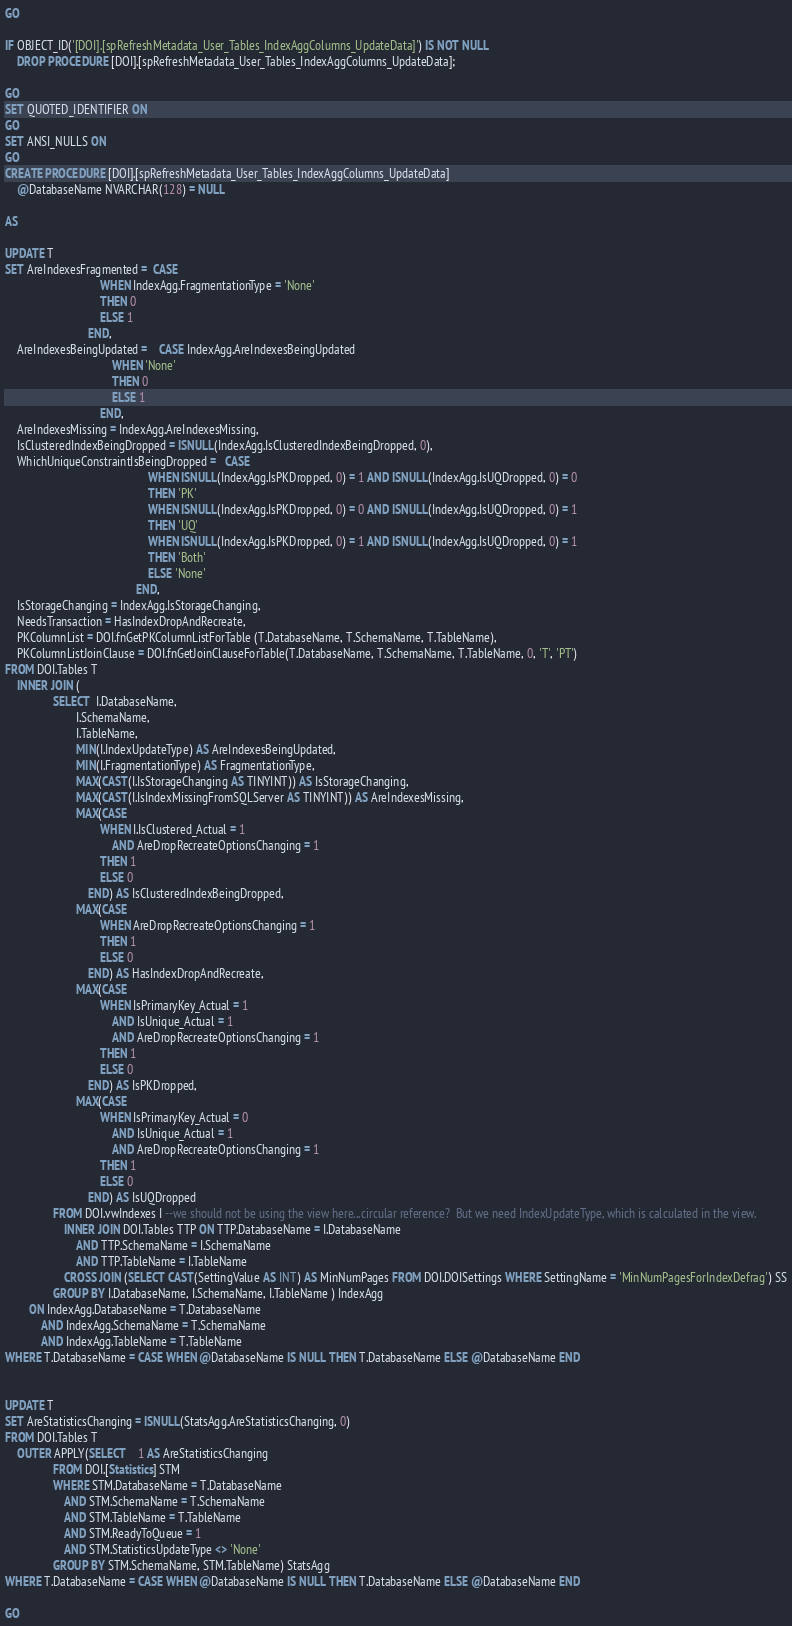<code> <loc_0><loc_0><loc_500><loc_500><_SQL_>
GO

IF OBJECT_ID('[DOI].[spRefreshMetadata_User_Tables_IndexAggColumns_UpdateData]') IS NOT NULL
	DROP PROCEDURE [DOI].[spRefreshMetadata_User_Tables_IndexAggColumns_UpdateData];

GO
SET QUOTED_IDENTIFIER ON
GO
SET ANSI_NULLS ON
GO
CREATE PROCEDURE [DOI].[spRefreshMetadata_User_Tables_IndexAggColumns_UpdateData]
    @DatabaseName NVARCHAR(128) = NULL

AS

UPDATE T
SET AreIndexesFragmented =  CASE 
			                    WHEN IndexAgg.FragmentationType = 'None'
			                    THEN 0
			                    ELSE 1 
		                    END,
	AreIndexesBeingUpdated =    CASE IndexAgg.AreIndexesBeingUpdated
			                        WHEN 'None'
			                        THEN 0
			                        ELSE 1
		                        END,
	AreIndexesMissing = IndexAgg.AreIndexesMissing,
    IsClusteredIndexBeingDropped = ISNULL(IndexAgg.IsClusteredIndexBeingDropped, 0),
	WhichUniqueConstraintIsBeingDropped =   CASE
		                                        WHEN ISNULL(IndexAgg.IsPKDropped, 0) = 1 AND ISNULL(IndexAgg.IsUQDropped, 0) = 0
		                                        THEN 'PK' 
		                                        WHEN ISNULL(IndexAgg.IsPKDropped, 0) = 0 AND ISNULL(IndexAgg.IsUQDropped, 0) = 1
		                                        THEN 'UQ'
		                                        WHEN ISNULL(IndexAgg.IsPKDropped, 0) = 1 AND ISNULL(IndexAgg.IsUQDropped, 0) = 1
		                                        THEN 'Both'
		                                        ELSE 'None'
	                                        END,
	IsStorageChanging = IndexAgg.IsStorageChanging,
	NeedsTransaction = HasIndexDropAndRecreate,
    PKColumnList = DOI.fnGetPKColumnListForTable (T.DatabaseName, T.SchemaName, T.TableName),
    PKColumnListJoinClause = DOI.fnGetJoinClauseForTable(T.DatabaseName, T.SchemaName, T.TableName, 0, 'T', 'PT')
FROM DOI.Tables T
    INNER JOIN (
                SELECT  I.DatabaseName,
                        I.SchemaName,
                        I.TableName,
                        MIN(I.IndexUpdateType) AS AreIndexesBeingUpdated,
                        MIN(I.FragmentationType) AS FragmentationType,
                        MAX(CAST(I.IsStorageChanging AS TINYINT)) AS IsStorageChanging,
                        MAX(CAST(I.IsIndexMissingFromSQLServer AS TINYINT)) AS AreIndexesMissing,
                        MAX(CASE 
                                WHEN I.IsClustered_Actual = 1
                                    AND AreDropRecreateOptionsChanging = 1
                                THEN 1
                                ELSE 0
                            END) AS IsClusteredIndexBeingDropped,
                        MAX(CASE 
				                WHEN AreDropRecreateOptionsChanging = 1
				                THEN 1 
				                ELSE 0 
			                END) AS HasIndexDropAndRecreate,
                        MAX(CASE
                                WHEN IsPrimaryKey_Actual = 1 
									AND IsUnique_Actual = 1
                                    AND AreDropRecreateOptionsChanging = 1
                                THEN 1
                                ELSE 0
                            END) AS IsPKDropped, 
                        MAX(CASE
                                WHEN IsPrimaryKey_Actual = 0 
									AND IsUnique_Actual = 1
                                    AND AreDropRecreateOptionsChanging = 1
                                THEN 1
                                ELSE 0
                            END) AS IsUQDropped
                FROM DOI.vwIndexes I --we should not be using the view here...circular reference?  But we need IndexUpdateType, which is calculated in the view.
                    INNER JOIN DOI.Tables TTP ON TTP.DatabaseName = I.DatabaseName
                        AND TTP.SchemaName = I.SchemaName
                        AND TTP.TableName = I.TableName
                    CROSS JOIN (SELECT CAST(SettingValue AS INT) AS MinNumPages FROM DOI.DOISettings WHERE SettingName = 'MinNumPagesForIndexDefrag') SS
                GROUP BY I.DatabaseName, I.SchemaName, I.TableName ) IndexAgg
        ON IndexAgg.DatabaseName = T.DatabaseName
            AND IndexAgg.SchemaName = T.SchemaName
            AND IndexAgg.TableName = T.TableName
WHERE T.DatabaseName = CASE WHEN @DatabaseName IS NULL THEN T.DatabaseName ELSE @DatabaseName END 


UPDATE T
SET AreStatisticsChanging = ISNULL(StatsAgg.AreStatisticsChanging, 0)
FROM DOI.Tables T
    OUTER APPLY(SELECT	1 AS AreStatisticsChanging
				FROM DOI.[Statistics] STM
				WHERE STM.DatabaseName = T.DatabaseName
                    AND STM.SchemaName = T.SchemaName
					AND STM.TableName = T.TableName
                    AND STM.ReadyToQueue = 1
					AND STM.StatisticsUpdateType <> 'None'
				GROUP BY STM.SchemaName, STM.TableName) StatsAgg
WHERE T.DatabaseName = CASE WHEN @DatabaseName IS NULL THEN T.DatabaseName ELSE @DatabaseName END 

GO
</code> 